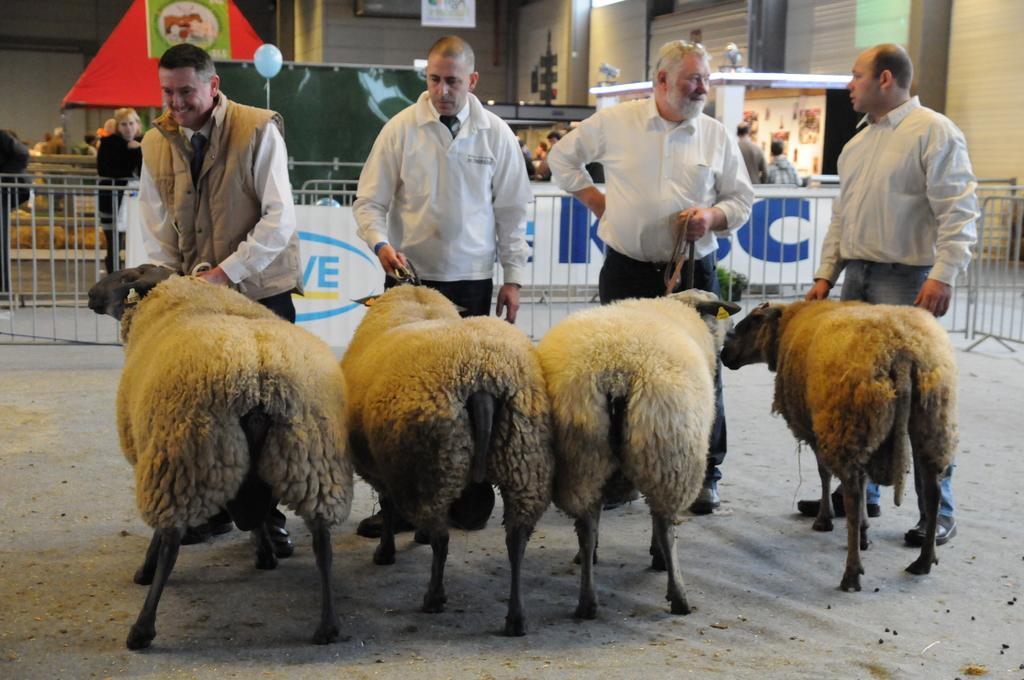In one or two sentences, can you explain what this image depicts? In the foreground of this image, there are four sheep holding by four men standing on the ground. In the background, there is railing, persons, stoles, balloons, and the wall. 